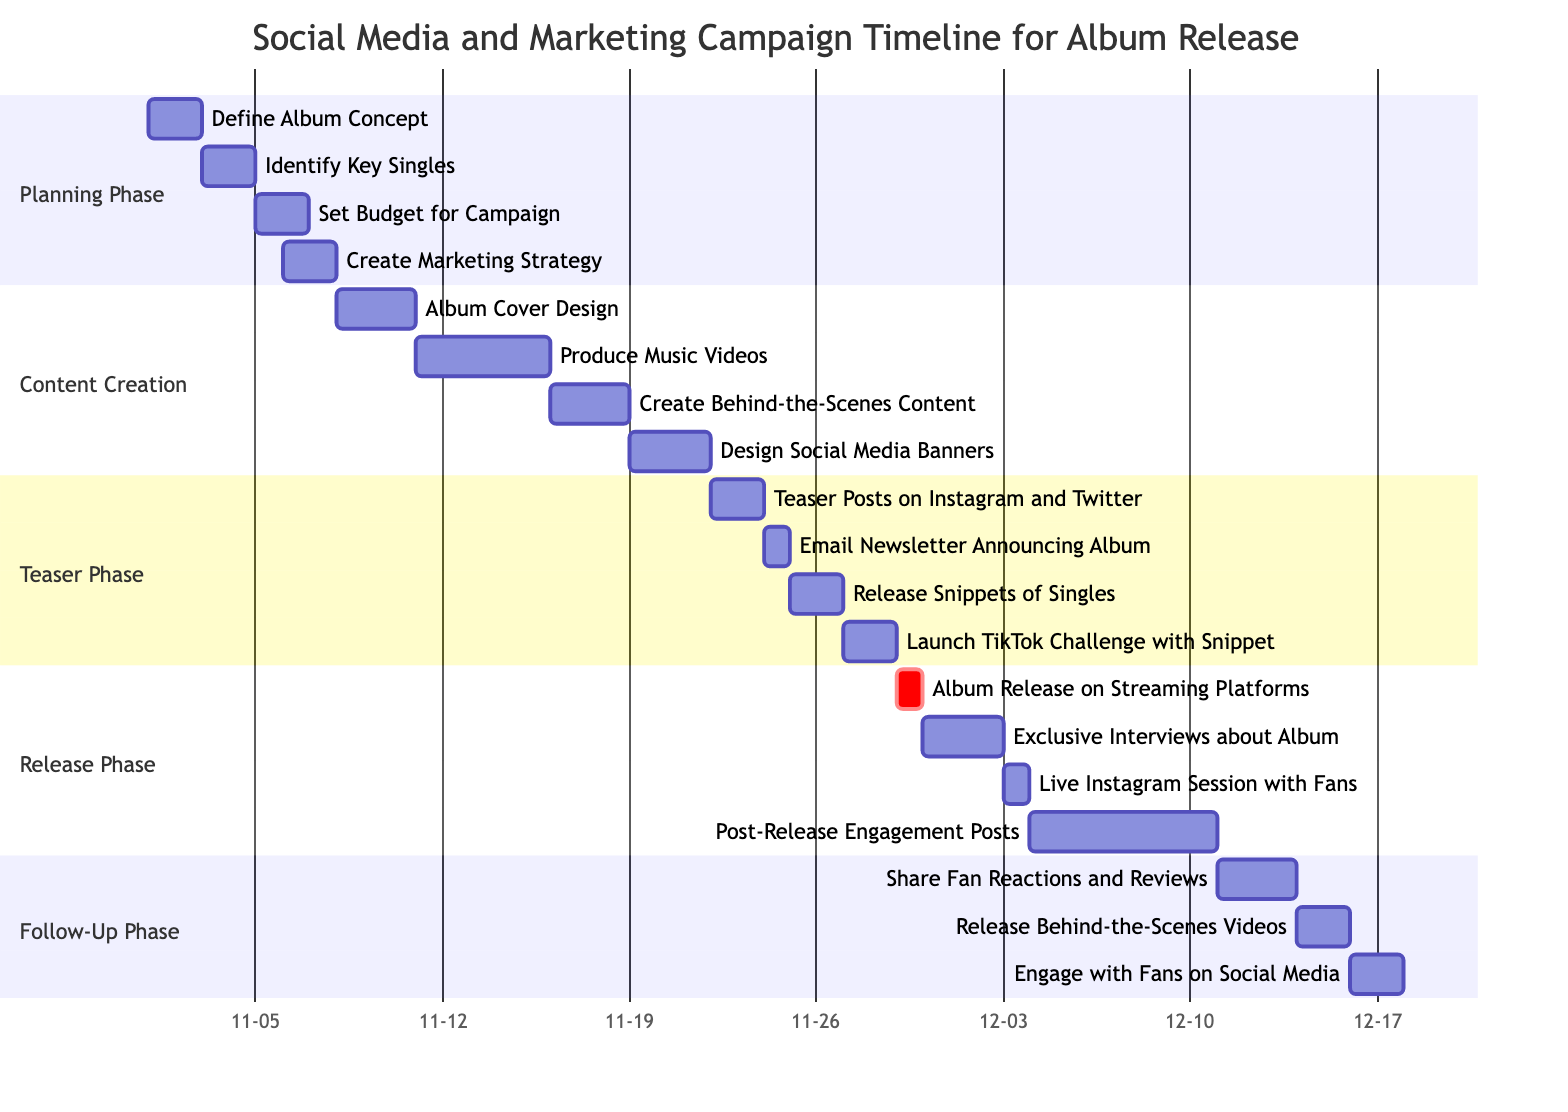How long is the Planning Phase? The Planning Phase starts on November 1, 2023, and ends on November 7, 2023. Calculating the duration by counting the days from start to end gives us 7 days.
Answer: 7 days Which task starts on November 25? Looking at the diagram, the task that begins on November 25 is "Release Snippets of Singles." This can be identified by checking the start dates of the tasks listed in the Teaser Phase section.
Answer: Release Snippets of Singles What is the last day for Post-Release Engagement Posts? The task "Post-Release Engagement Posts" has an end date of December 10, 2023, as indicated in the Release Phase section of the Gantt chart. This end date is stated directly in the diagram under that task.
Answer: December 10 How many subtasks are listed under Content Creation? Under the Content Creation section, there are four subtasks: "Album Cover Design," "Produce Music Videos," "Create Behind-the-Scenes Content," and "Design Social Media Banners." By counting these listed items, we find there are four.
Answer: 4 Which phase contains the task "Launch TikTok Challenge with Snippet"? The task "Launch TikTok Challenge with Snippet" is found in the Teaser Phase section. This can be verified by looking at the list of tasks under each phase in the diagram.
Answer: Teaser Phase How many total phases are displayed in the diagram? The diagram shows a total of five distinct phases: Planning Phase, Content Creation, Teaser Phase, Release Phase, and Follow-Up Phase. Counting these phases gives a total of five.
Answer: 5 What task overlaps with the Album Release on Streaming Platforms? The task "Exclusive Interviews about Album" starts the day after the Album Release on November 30 and overlaps in timing because it begins immediately after the release. Thus, these two tasks share that immediate time frame.
Answer: Exclusive Interviews about Album When is the email newsletter announcing the album scheduled? The task "Email Newsletter Announcing Album" is scheduled for November 24, 2023, as indicated in the Teaser Phase section of the Gantt chart. This specific date is explicitly stated under the respective task.
Answer: November 24 